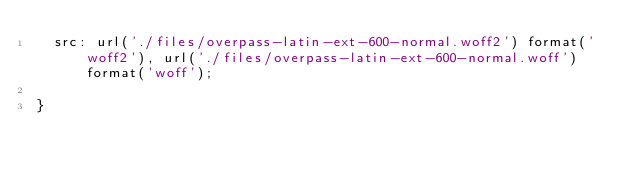Convert code to text. <code><loc_0><loc_0><loc_500><loc_500><_CSS_>  src: url('./files/overpass-latin-ext-600-normal.woff2') format('woff2'), url('./files/overpass-latin-ext-600-normal.woff') format('woff');
  
}
</code> 